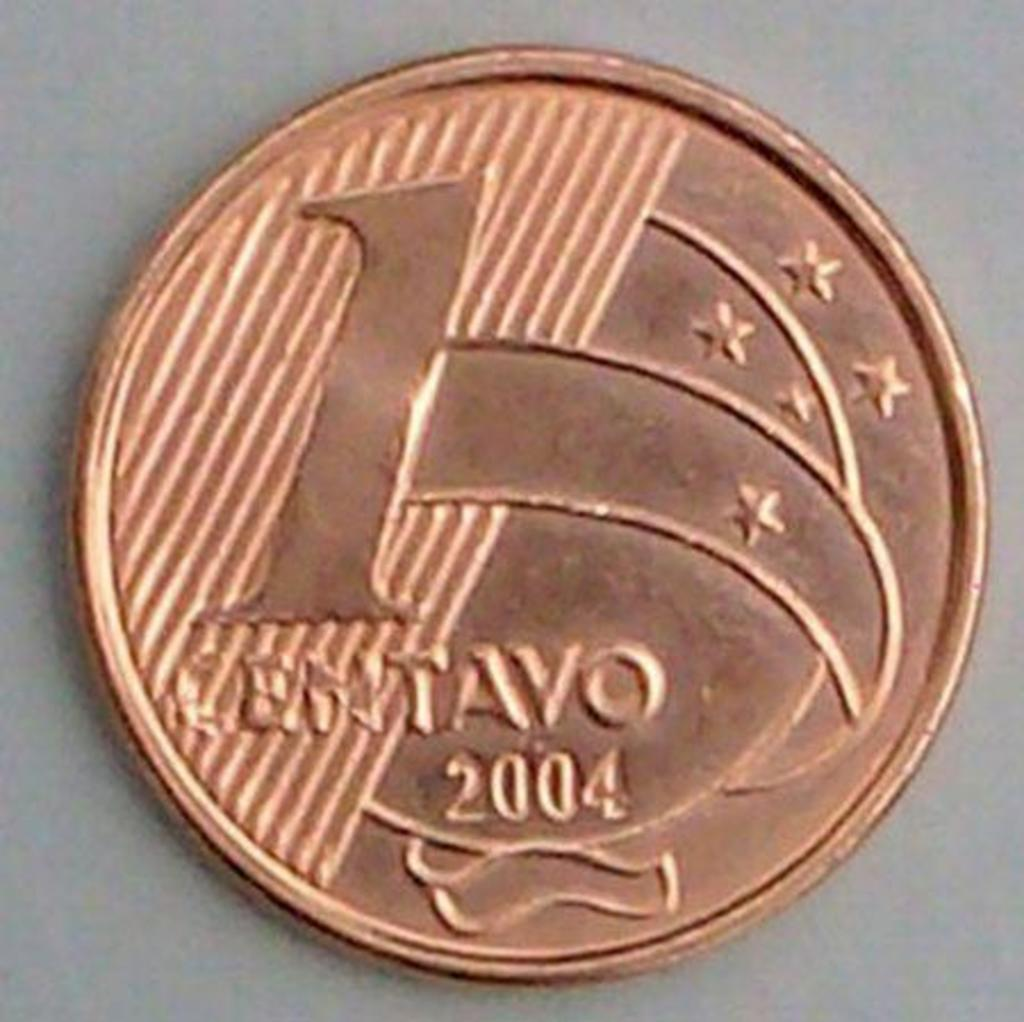<image>
Describe the image concisely. Copper coin that says Centavo 2004 with stars on it. 